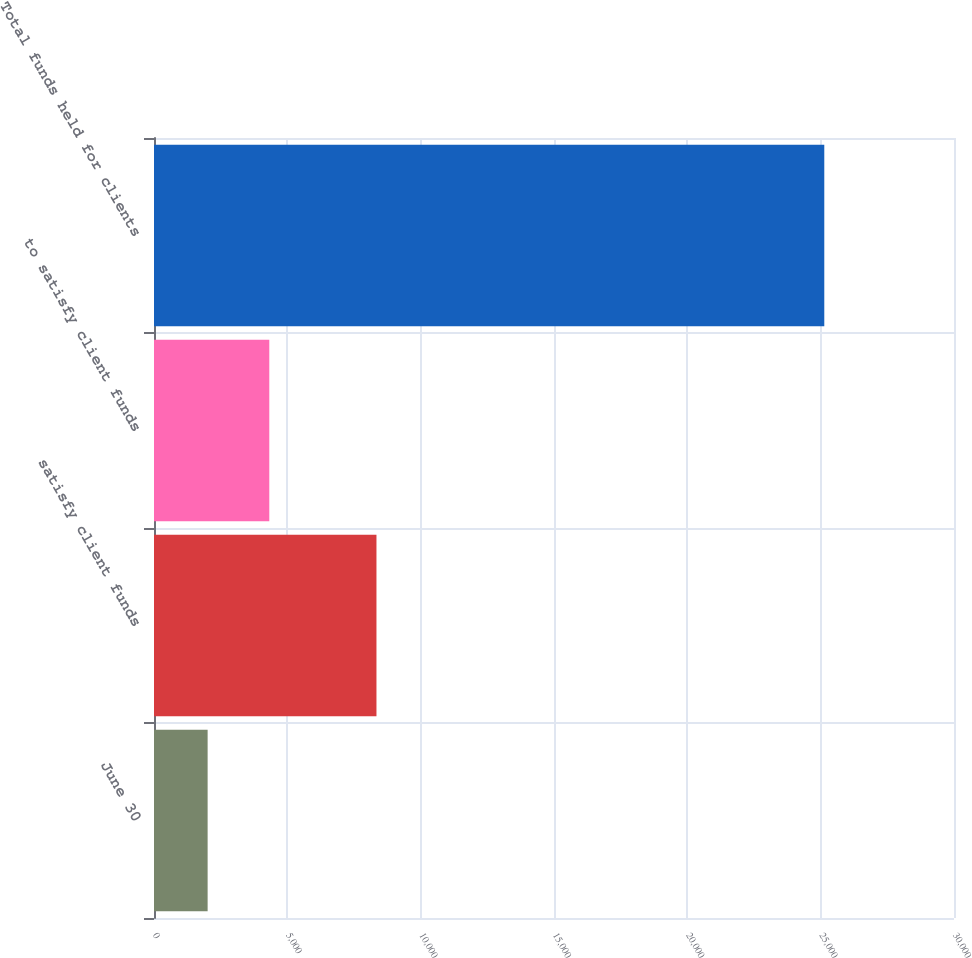Convert chart to OTSL. <chart><loc_0><loc_0><loc_500><loc_500><bar_chart><fcel>June 30<fcel>satisfy client funds<fcel>to satisfy client funds<fcel>Total funds held for clients<nl><fcel>2011<fcel>8342.4<fcel>4323.46<fcel>25135.6<nl></chart> 